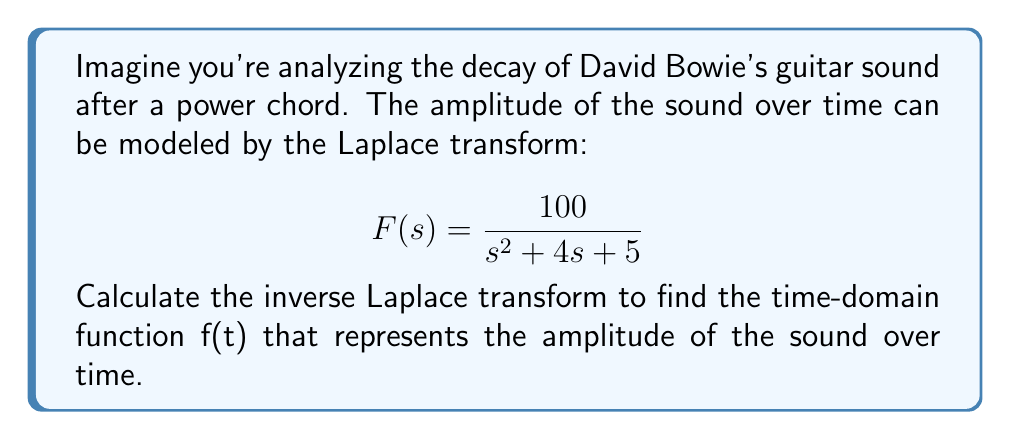Could you help me with this problem? To find the inverse Laplace transform, we'll follow these steps:

1) First, we need to factor the denominator of F(s):
   $$s^2 + 4s + 5 = (s+2)^2 + 1$$

2) Now we can rewrite F(s) as:
   $$F(s) = \frac{100}{(s+2)^2 + 1^2}$$

3) This form matches the standard form for the inverse Laplace transform of a damped sinusoid:
   $$\mathcal{L}^{-1}\left\{\frac{a}{(s+\alpha)^2 + \beta^2}\right\} = \frac{a}{\beta}e^{-\alpha t}\sin(\beta t)$$

4) In our case:
   $a = 100$
   $\alpha = 2$
   $\beta = 1$

5) Substituting these values into the standard form:

   $$f(t) = \frac{100}{1}e^{-2t}\sin(1t)$$

6) Simplifying:

   $$f(t) = 100e^{-2t}\sin(t)$$

This function represents the amplitude of the guitar sound over time, showing a decaying sinusoidal wave.
Answer: $$f(t) = 100e^{-2t}\sin(t)$$ 